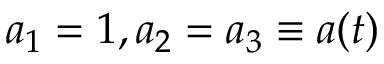<formula> <loc_0><loc_0><loc_500><loc_500>a _ { 1 } = 1 , a _ { 2 } = a _ { 3 } \equiv a ( t )</formula> 